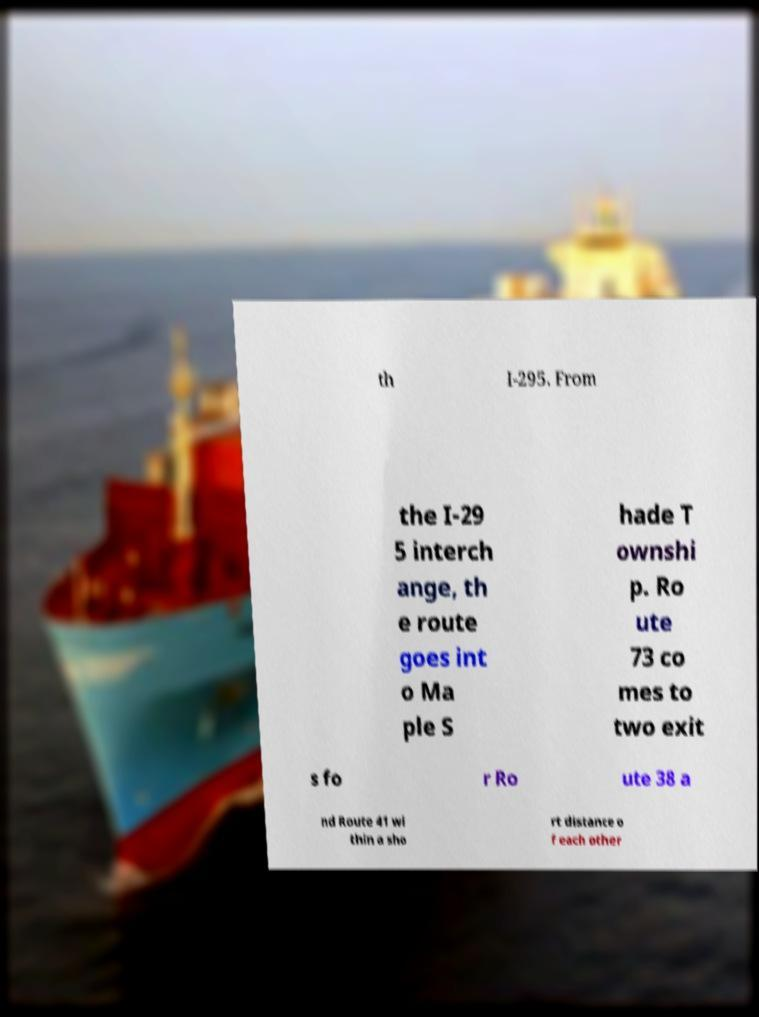There's text embedded in this image that I need extracted. Can you transcribe it verbatim? th I-295. From the I-29 5 interch ange, th e route goes int o Ma ple S hade T ownshi p. Ro ute 73 co mes to two exit s fo r Ro ute 38 a nd Route 41 wi thin a sho rt distance o f each other 